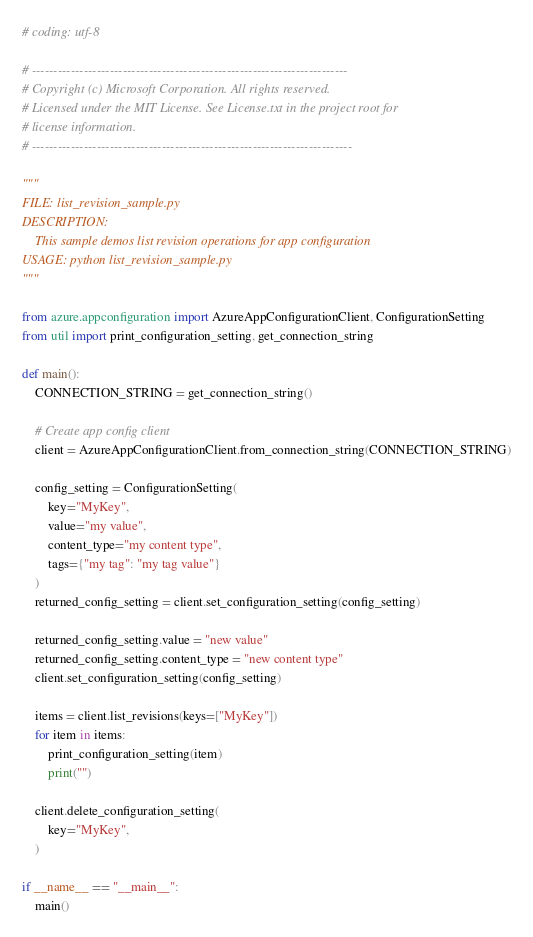Convert code to text. <code><loc_0><loc_0><loc_500><loc_500><_Python_># coding: utf-8

# -------------------------------------------------------------------------
# Copyright (c) Microsoft Corporation. All rights reserved.
# Licensed under the MIT License. See License.txt in the project root for
# license information.
# --------------------------------------------------------------------------

"""
FILE: list_revision_sample.py
DESCRIPTION:
    This sample demos list revision operations for app configuration
USAGE: python list_revision_sample.py
"""

from azure.appconfiguration import AzureAppConfigurationClient, ConfigurationSetting
from util import print_configuration_setting, get_connection_string

def main():
    CONNECTION_STRING = get_connection_string()

    # Create app config client
    client = AzureAppConfigurationClient.from_connection_string(CONNECTION_STRING)

    config_setting = ConfigurationSetting(
        key="MyKey",
        value="my value",
        content_type="my content type",
        tags={"my tag": "my tag value"}
    )
    returned_config_setting = client.set_configuration_setting(config_setting)

    returned_config_setting.value = "new value"
    returned_config_setting.content_type = "new content type"
    client.set_configuration_setting(config_setting)

    items = client.list_revisions(keys=["MyKey"])
    for item in items:
        print_configuration_setting(item)
        print("")

    client.delete_configuration_setting(
        key="MyKey",
    )

if __name__ == "__main__":
    main()
</code> 